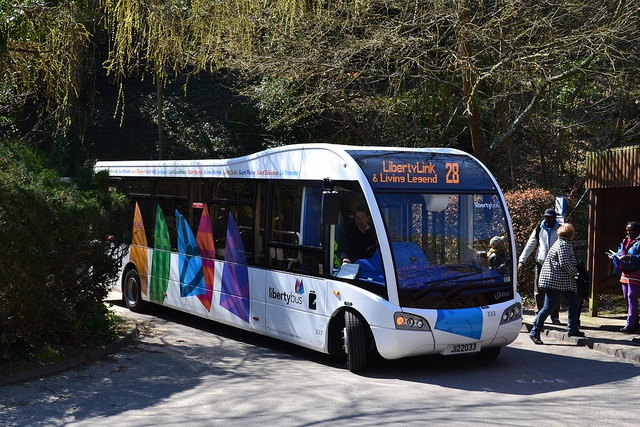Describe the objects in this image and their specific colors. I can see bus in black, navy, white, and gray tones, people in black, gray, and lightgray tones, people in black, navy, lavender, and maroon tones, people in black, gray, white, and darkgray tones, and people in black, navy, gray, and lightgray tones in this image. 